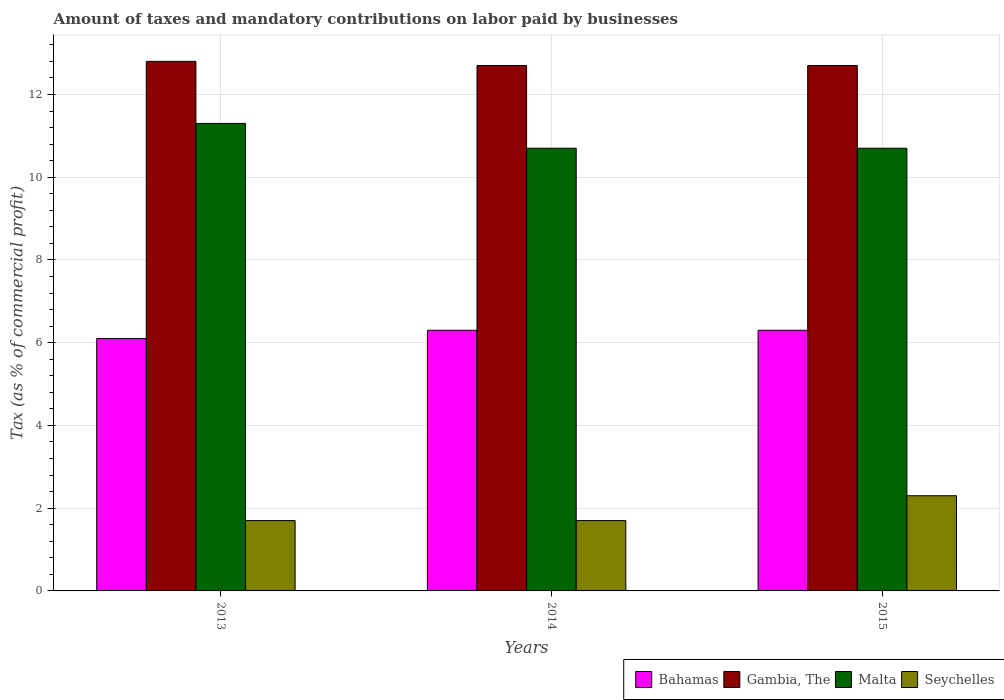How many groups of bars are there?
Your answer should be very brief. 3. Are the number of bars per tick equal to the number of legend labels?
Your answer should be compact. Yes. How many bars are there on the 1st tick from the right?
Ensure brevity in your answer.  4. What is the label of the 3rd group of bars from the left?
Give a very brief answer. 2015. What is the percentage of taxes paid by businesses in Malta in 2013?
Give a very brief answer. 11.3. In which year was the percentage of taxes paid by businesses in Seychelles maximum?
Provide a succinct answer. 2015. What is the total percentage of taxes paid by businesses in Gambia, The in the graph?
Keep it short and to the point. 38.2. What is the difference between the percentage of taxes paid by businesses in Gambia, The in 2013 and that in 2015?
Provide a succinct answer. 0.1. What is the difference between the percentage of taxes paid by businesses in Gambia, The in 2015 and the percentage of taxes paid by businesses in Malta in 2013?
Offer a terse response. 1.4. What is the average percentage of taxes paid by businesses in Bahamas per year?
Your answer should be compact. 6.23. In the year 2013, what is the difference between the percentage of taxes paid by businesses in Gambia, The and percentage of taxes paid by businesses in Bahamas?
Make the answer very short. 6.7. In how many years, is the percentage of taxes paid by businesses in Malta greater than 8 %?
Your answer should be compact. 3. What is the ratio of the percentage of taxes paid by businesses in Seychelles in 2014 to that in 2015?
Keep it short and to the point. 0.74. Is the difference between the percentage of taxes paid by businesses in Gambia, The in 2013 and 2015 greater than the difference between the percentage of taxes paid by businesses in Bahamas in 2013 and 2015?
Your answer should be very brief. Yes. What is the difference between the highest and the second highest percentage of taxes paid by businesses in Seychelles?
Give a very brief answer. 0.6. What is the difference between the highest and the lowest percentage of taxes paid by businesses in Bahamas?
Provide a short and direct response. 0.2. Is it the case that in every year, the sum of the percentage of taxes paid by businesses in Bahamas and percentage of taxes paid by businesses in Malta is greater than the sum of percentage of taxes paid by businesses in Gambia, The and percentage of taxes paid by businesses in Seychelles?
Offer a very short reply. Yes. What does the 1st bar from the left in 2013 represents?
Your response must be concise. Bahamas. What does the 2nd bar from the right in 2015 represents?
Offer a terse response. Malta. How many bars are there?
Provide a short and direct response. 12. Are all the bars in the graph horizontal?
Ensure brevity in your answer.  No. Are the values on the major ticks of Y-axis written in scientific E-notation?
Make the answer very short. No. Where does the legend appear in the graph?
Make the answer very short. Bottom right. What is the title of the graph?
Offer a terse response. Amount of taxes and mandatory contributions on labor paid by businesses. Does "Bahrain" appear as one of the legend labels in the graph?
Offer a very short reply. No. What is the label or title of the X-axis?
Give a very brief answer. Years. What is the label or title of the Y-axis?
Make the answer very short. Tax (as % of commercial profit). What is the Tax (as % of commercial profit) of Malta in 2013?
Provide a succinct answer. 11.3. What is the Tax (as % of commercial profit) in Bahamas in 2014?
Offer a terse response. 6.3. What is the Tax (as % of commercial profit) in Gambia, The in 2014?
Your answer should be very brief. 12.7. What is the Tax (as % of commercial profit) in Malta in 2014?
Give a very brief answer. 10.7. What is the Tax (as % of commercial profit) of Seychelles in 2014?
Offer a terse response. 1.7. What is the Tax (as % of commercial profit) of Bahamas in 2015?
Keep it short and to the point. 6.3. What is the Tax (as % of commercial profit) in Seychelles in 2015?
Your answer should be compact. 2.3. Across all years, what is the maximum Tax (as % of commercial profit) in Bahamas?
Make the answer very short. 6.3. Across all years, what is the maximum Tax (as % of commercial profit) in Gambia, The?
Your answer should be very brief. 12.8. Across all years, what is the maximum Tax (as % of commercial profit) in Malta?
Ensure brevity in your answer.  11.3. Across all years, what is the minimum Tax (as % of commercial profit) of Bahamas?
Offer a terse response. 6.1. Across all years, what is the minimum Tax (as % of commercial profit) in Gambia, The?
Make the answer very short. 12.7. Across all years, what is the minimum Tax (as % of commercial profit) of Seychelles?
Your answer should be very brief. 1.7. What is the total Tax (as % of commercial profit) of Bahamas in the graph?
Make the answer very short. 18.7. What is the total Tax (as % of commercial profit) of Gambia, The in the graph?
Provide a succinct answer. 38.2. What is the total Tax (as % of commercial profit) in Malta in the graph?
Ensure brevity in your answer.  32.7. What is the difference between the Tax (as % of commercial profit) in Bahamas in 2013 and that in 2014?
Offer a very short reply. -0.2. What is the difference between the Tax (as % of commercial profit) in Gambia, The in 2013 and that in 2014?
Offer a very short reply. 0.1. What is the difference between the Tax (as % of commercial profit) in Bahamas in 2014 and that in 2015?
Keep it short and to the point. 0. What is the difference between the Tax (as % of commercial profit) of Seychelles in 2014 and that in 2015?
Provide a succinct answer. -0.6. What is the difference between the Tax (as % of commercial profit) of Bahamas in 2013 and the Tax (as % of commercial profit) of Gambia, The in 2014?
Provide a short and direct response. -6.6. What is the difference between the Tax (as % of commercial profit) of Bahamas in 2013 and the Tax (as % of commercial profit) of Malta in 2014?
Give a very brief answer. -4.6. What is the difference between the Tax (as % of commercial profit) of Bahamas in 2013 and the Tax (as % of commercial profit) of Seychelles in 2014?
Keep it short and to the point. 4.4. What is the difference between the Tax (as % of commercial profit) of Malta in 2013 and the Tax (as % of commercial profit) of Seychelles in 2014?
Your answer should be compact. 9.6. What is the difference between the Tax (as % of commercial profit) in Bahamas in 2013 and the Tax (as % of commercial profit) in Gambia, The in 2015?
Provide a short and direct response. -6.6. What is the difference between the Tax (as % of commercial profit) of Bahamas in 2013 and the Tax (as % of commercial profit) of Malta in 2015?
Your answer should be compact. -4.6. What is the difference between the Tax (as % of commercial profit) in Gambia, The in 2013 and the Tax (as % of commercial profit) in Malta in 2015?
Your response must be concise. 2.1. What is the difference between the Tax (as % of commercial profit) of Gambia, The in 2013 and the Tax (as % of commercial profit) of Seychelles in 2015?
Ensure brevity in your answer.  10.5. What is the difference between the Tax (as % of commercial profit) in Bahamas in 2014 and the Tax (as % of commercial profit) in Gambia, The in 2015?
Your answer should be very brief. -6.4. What is the average Tax (as % of commercial profit) in Bahamas per year?
Give a very brief answer. 6.23. What is the average Tax (as % of commercial profit) in Gambia, The per year?
Offer a very short reply. 12.73. What is the average Tax (as % of commercial profit) of Malta per year?
Give a very brief answer. 10.9. In the year 2013, what is the difference between the Tax (as % of commercial profit) in Bahamas and Tax (as % of commercial profit) in Gambia, The?
Make the answer very short. -6.7. In the year 2013, what is the difference between the Tax (as % of commercial profit) of Gambia, The and Tax (as % of commercial profit) of Malta?
Keep it short and to the point. 1.5. In the year 2013, what is the difference between the Tax (as % of commercial profit) of Malta and Tax (as % of commercial profit) of Seychelles?
Offer a very short reply. 9.6. In the year 2014, what is the difference between the Tax (as % of commercial profit) of Bahamas and Tax (as % of commercial profit) of Malta?
Your answer should be very brief. -4.4. In the year 2014, what is the difference between the Tax (as % of commercial profit) in Bahamas and Tax (as % of commercial profit) in Seychelles?
Your answer should be very brief. 4.6. In the year 2015, what is the difference between the Tax (as % of commercial profit) in Bahamas and Tax (as % of commercial profit) in Malta?
Your answer should be very brief. -4.4. In the year 2015, what is the difference between the Tax (as % of commercial profit) in Bahamas and Tax (as % of commercial profit) in Seychelles?
Provide a short and direct response. 4. In the year 2015, what is the difference between the Tax (as % of commercial profit) in Gambia, The and Tax (as % of commercial profit) in Seychelles?
Your answer should be compact. 10.4. What is the ratio of the Tax (as % of commercial profit) in Bahamas in 2013 to that in 2014?
Give a very brief answer. 0.97. What is the ratio of the Tax (as % of commercial profit) of Gambia, The in 2013 to that in 2014?
Your response must be concise. 1.01. What is the ratio of the Tax (as % of commercial profit) of Malta in 2013 to that in 2014?
Make the answer very short. 1.06. What is the ratio of the Tax (as % of commercial profit) of Seychelles in 2013 to that in 2014?
Offer a very short reply. 1. What is the ratio of the Tax (as % of commercial profit) in Bahamas in 2013 to that in 2015?
Keep it short and to the point. 0.97. What is the ratio of the Tax (as % of commercial profit) in Gambia, The in 2013 to that in 2015?
Provide a succinct answer. 1.01. What is the ratio of the Tax (as % of commercial profit) of Malta in 2013 to that in 2015?
Provide a short and direct response. 1.06. What is the ratio of the Tax (as % of commercial profit) in Seychelles in 2013 to that in 2015?
Ensure brevity in your answer.  0.74. What is the ratio of the Tax (as % of commercial profit) in Bahamas in 2014 to that in 2015?
Offer a terse response. 1. What is the ratio of the Tax (as % of commercial profit) in Malta in 2014 to that in 2015?
Your answer should be very brief. 1. What is the ratio of the Tax (as % of commercial profit) in Seychelles in 2014 to that in 2015?
Provide a short and direct response. 0.74. What is the difference between the highest and the second highest Tax (as % of commercial profit) in Bahamas?
Your answer should be compact. 0. What is the difference between the highest and the second highest Tax (as % of commercial profit) of Gambia, The?
Your answer should be very brief. 0.1. What is the difference between the highest and the second highest Tax (as % of commercial profit) of Seychelles?
Provide a short and direct response. 0.6. What is the difference between the highest and the lowest Tax (as % of commercial profit) in Bahamas?
Offer a terse response. 0.2. What is the difference between the highest and the lowest Tax (as % of commercial profit) of Malta?
Make the answer very short. 0.6. What is the difference between the highest and the lowest Tax (as % of commercial profit) of Seychelles?
Keep it short and to the point. 0.6. 